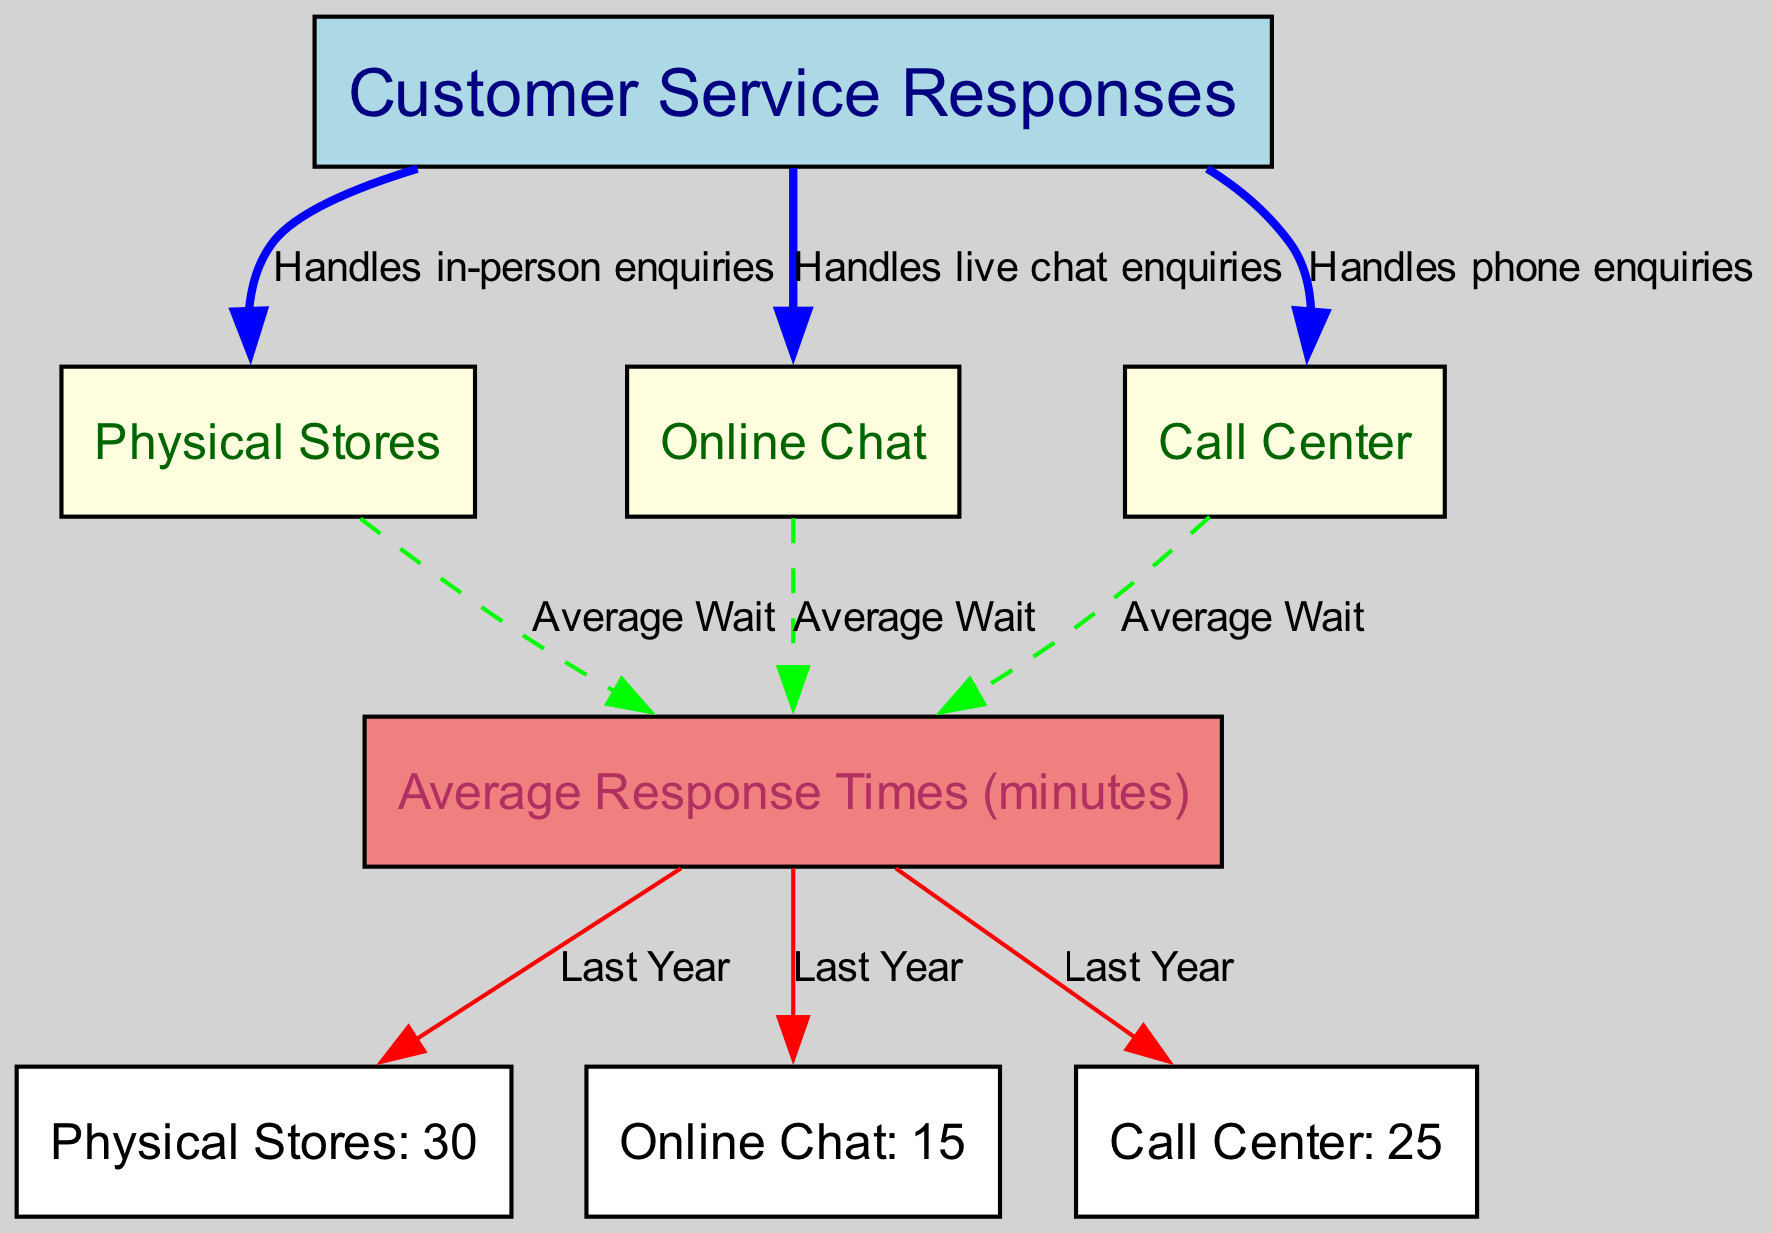What is the average response time for Physical Stores? The diagram indicates that the average response time for Physical Stores is shown as "30" next to the node labeled "Physical Stores: 30."
Answer: 30 What type of enquiries does Online Chat handle? The connection between "Customer Service Responses" and "Online Chat" is labeled "Handles live chat enquiries," indicating the service type.
Answer: Live chat enquiries How many nodes are present in this diagram? There are six unique nodes in the diagram, which include Customer Service Responses, Physical Stores, Online Chat, Call Center, Average Response Times, and individual average response times.
Answer: Six What relationship exists between Call Center and Average Response Times? The diagram shows an edge from "Call Center" to "Average Response Times," labeled "Average Wait," which indicates that it contributes to the calculation of average wait times.
Answer: Average Wait What is the average response time for Online Chat? The diagram states "Online Chat: 15" next to the respective node, indicating the average wait time for this service channel.
Answer: 15 Which customer service method has the longest average response time? By comparing the average response times in the diagram, Physical Stores (30 minutes) has the highest average response time among the three methods.
Answer: Physical Stores What color represents the Average Response Times node? The Average Response Times node is filled with light coral color, as indicated in the diagram settings for node colors.
Answer: Light coral What is the total average response time for all three customer service channels? Combining the individual average response times of Physical Stores (30), Online Chat (15), and Call Center (25) results in a total of 70 minutes.
Answer: 70 What does the edge from Online Chat to Average Response Times imply? The edge labeled "Average Wait" from "Online Chat" to "Average Response Times" indicates that online chats contribute to overall average wait time statistics for the service.
Answer: Average Wait 